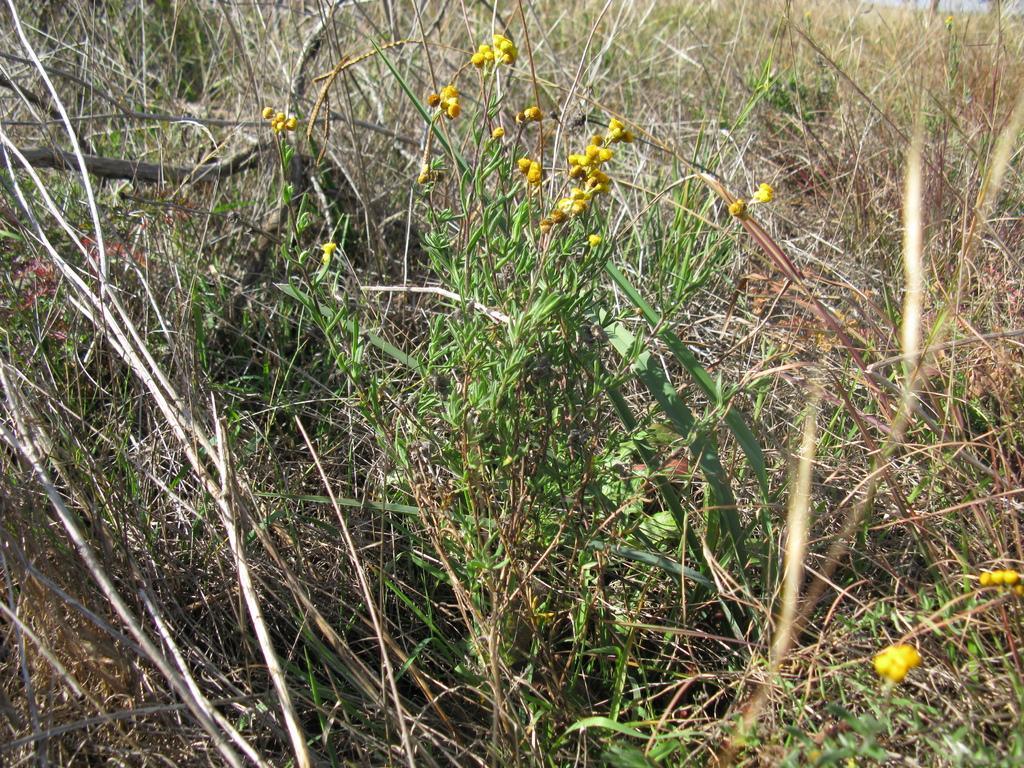Can you describe this image briefly? This picture is consists of grass field in the image. 